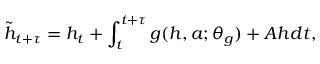<formula> <loc_0><loc_0><loc_500><loc_500>\tilde { h } _ { t + \tau } = h _ { t } + \int _ { t } ^ { t + \tau } g ( h , a ; \theta _ { g } ) + A h d t ,</formula> 